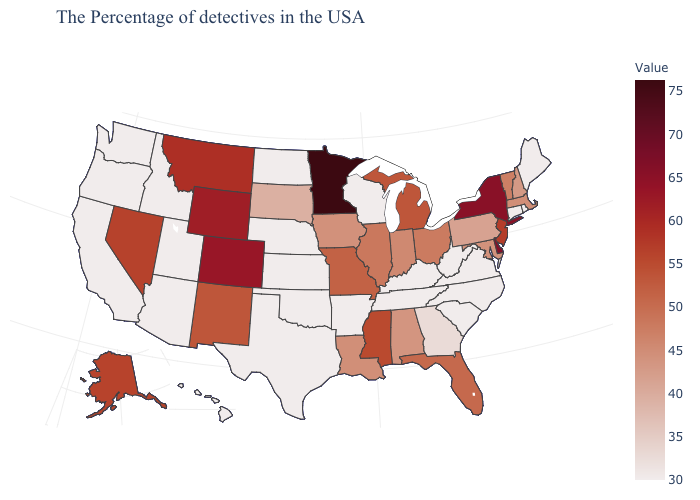Which states have the lowest value in the Northeast?
Be succinct. Maine, Rhode Island, Connecticut. Does Vermont have a higher value than Georgia?
Answer briefly. Yes. Does New Mexico have the highest value in the USA?
Concise answer only. No. Among the states that border South Carolina , does Georgia have the lowest value?
Short answer required. No. Among the states that border Colorado , which have the highest value?
Short answer required. Wyoming. Does the map have missing data?
Give a very brief answer. No. 